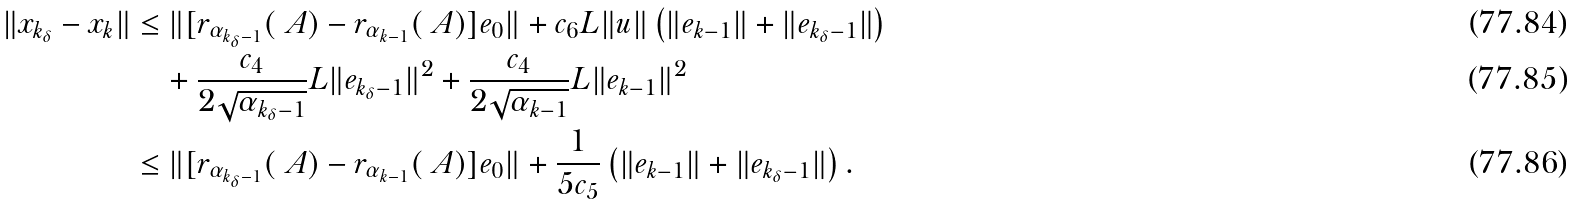Convert formula to latex. <formula><loc_0><loc_0><loc_500><loc_500>\| x _ { k _ { \delta } } - x _ { k } \| & \leq \| [ r _ { \alpha _ { k _ { \delta } - 1 } } ( \ A ) - r _ { \alpha _ { k - 1 } } ( \ A ) ] e _ { 0 } \| + c _ { 6 } L \| u \| \left ( \| e _ { k - 1 } \| + \| e _ { k _ { \delta } - 1 } \| \right ) \\ & \quad + \frac { c _ { 4 } } { 2 \sqrt { \alpha _ { k _ { \delta } - 1 } } } L \| e _ { k _ { \delta } - 1 } \| ^ { 2 } + \frac { c _ { 4 } } { 2 \sqrt { \alpha _ { k - 1 } } } L \| e _ { k - 1 } \| ^ { 2 } \\ & \leq \| [ r _ { \alpha _ { k _ { \delta } - 1 } } ( \ A ) - r _ { \alpha _ { k - 1 } } ( \ A ) ] e _ { 0 } \| + \frac { 1 } { 5 c _ { 5 } } \left ( \| e _ { k - 1 } \| + \| e _ { k _ { \delta } - 1 } \| \right ) .</formula> 